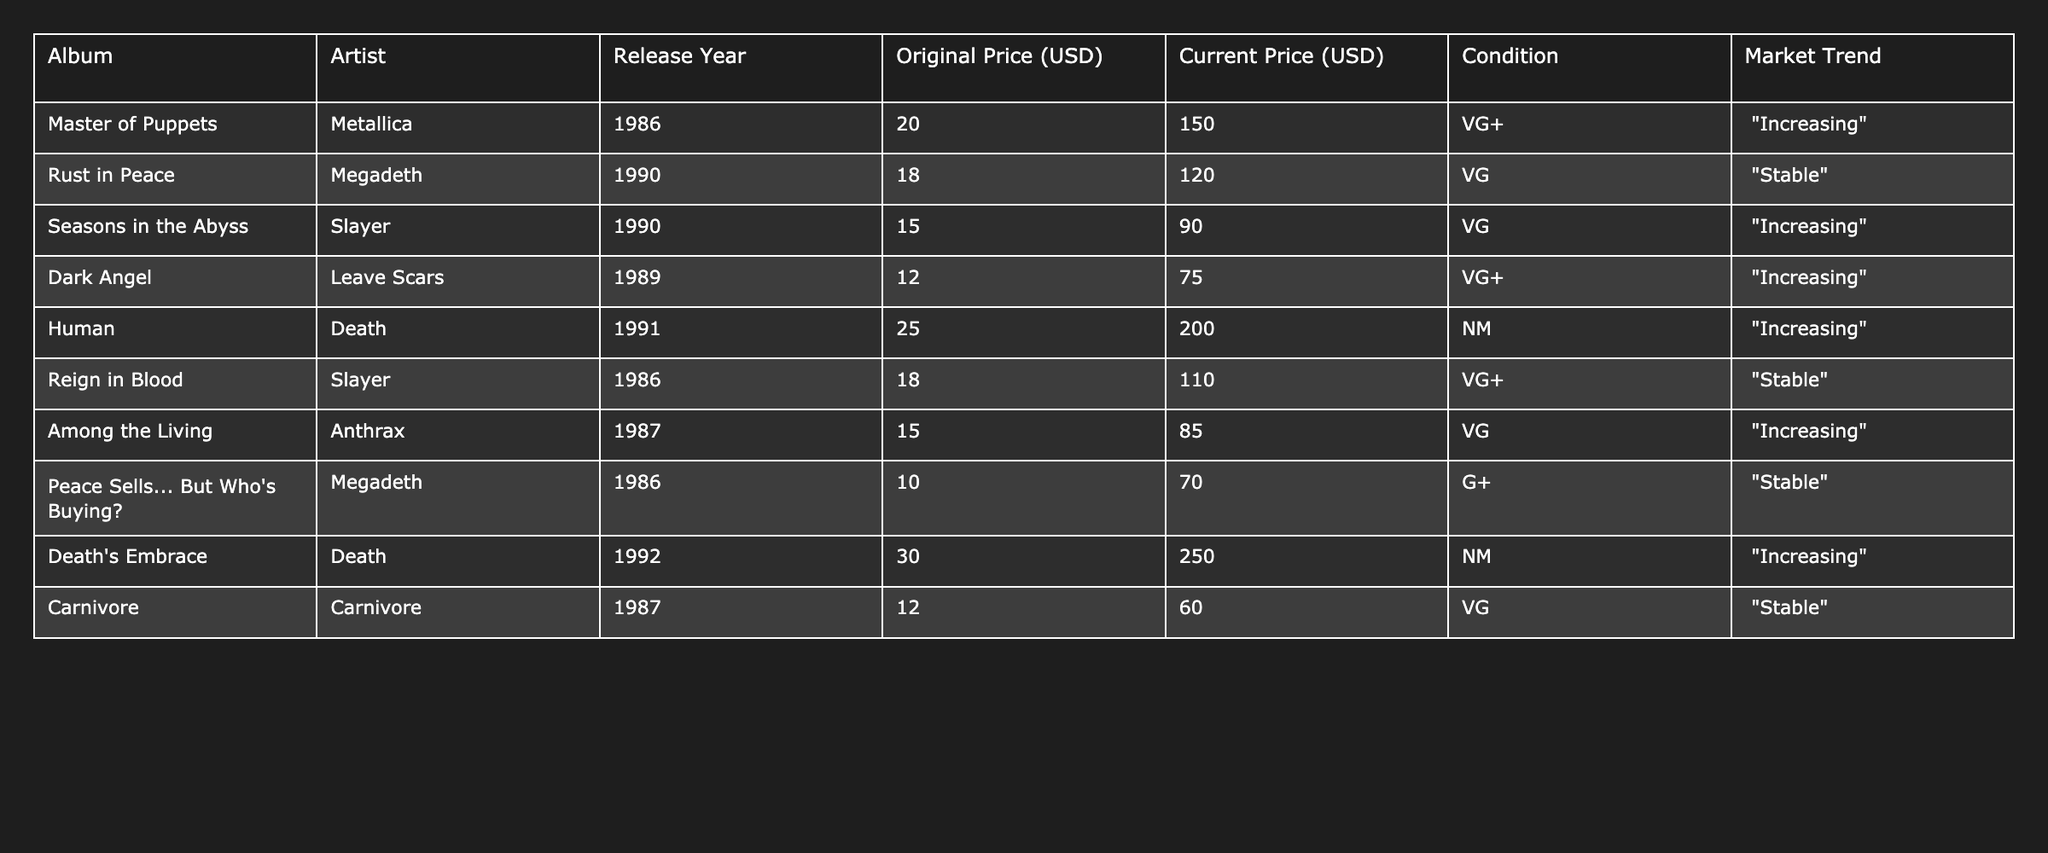What is the current price of "Master of Puppets"? The table shows that the current price for "Master of Puppets" by Metallica is listed as 150.00 USD.
Answer: 150.00 Which album has the highest current price? By examining the "Current Price (USD)" column, "Death's Embrace" by Death has the highest current price at 250.00 USD.
Answer: Death's Embrace What is the average original price of the albums listed? To find the average, we sum the original prices: 20 + 18 + 15 + 12 + 25 + 18 + 15 + 10 + 30 + 12 =  150. Now, divide by the number of albums (10), which gives us 150 / 10 = 15.00 USD.
Answer: 15.00 Are all albums from the year 1986 increasing in price? From the table, both "Master of Puppets" and "Reign in Blood," released in 1986, are experiencing an increasing or stable market trend. This indicates not all are strictly increasing.
Answer: No Which artist has the most albums listed in the table? By checking the artist column, Metallica, Megadeth, and Death appear twice each, while others appear once, making them the top artists with the most presence.
Answer: Metallica, Megadeth, and Death What is the difference between the highest and lowest current prices? The highest current price is 250.00 USD ("Death's Embrace") and the lowest is 60.00 USD ("Carnivore"). So, the difference is 250 - 60 = 190.00 USD.
Answer: 190.00 Is "Human" by Death the only album rated as NM? Reviewing the condition column, "Human" is indeed marked as NM, and there are no other albums in this condition listed in the table.
Answer: Yes How many albums have a market trend categorized as increasing? By counting the entries listed as "Increasing," we find that five albums fit this trend.
Answer: 5 What is the total current value of all albums listed? To find the total current value, we sum all the current prices: 150 + 120 + 90 + 75 + 200 + 110 + 85 + 70 + 250 + 60 = 1,220.00 USD.
Answer: 1,220.00 